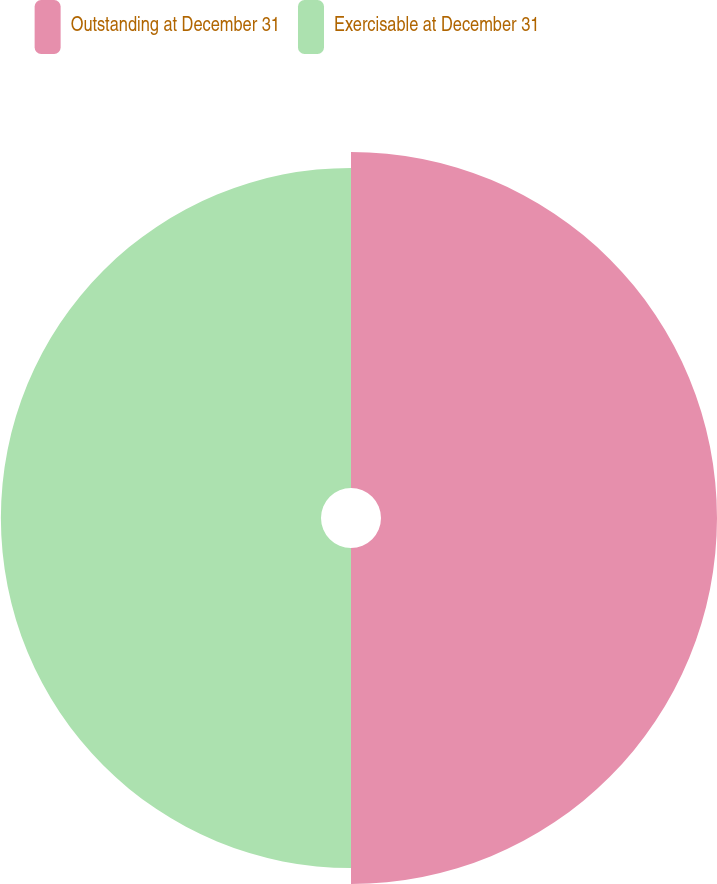Convert chart. <chart><loc_0><loc_0><loc_500><loc_500><pie_chart><fcel>Outstanding at December 31<fcel>Exercisable at December 31<nl><fcel>51.21%<fcel>48.79%<nl></chart> 